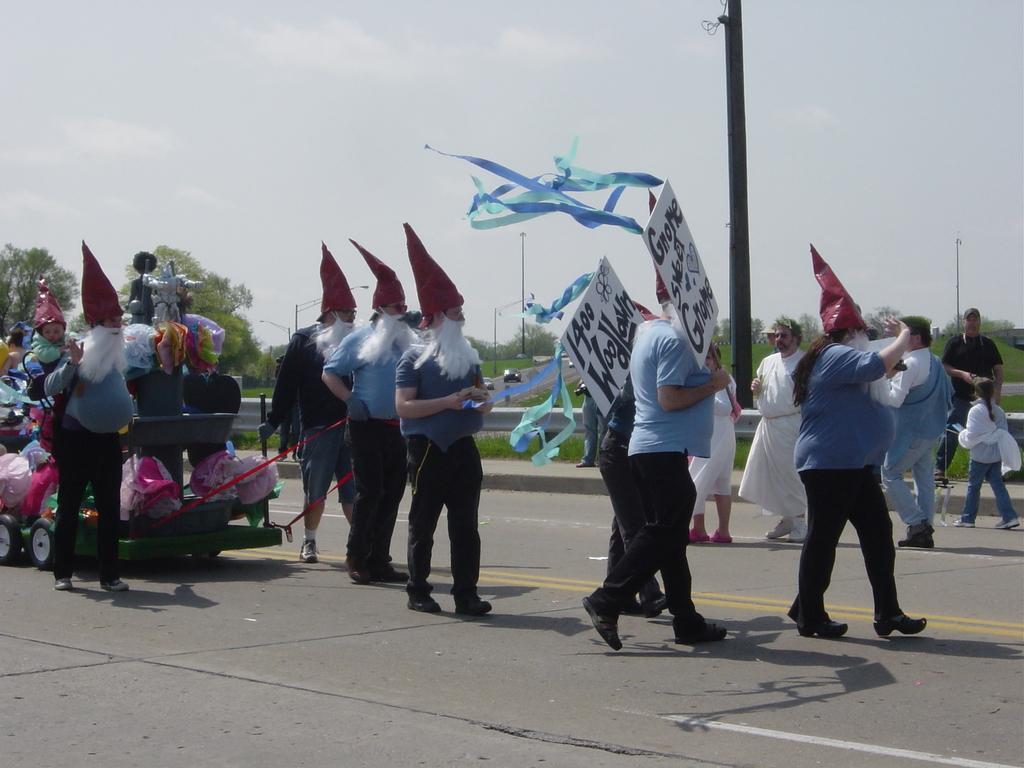Could you give a brief overview of what you see in this image? In this image we can see there are few people walking on the road, few are wearing a costume of a joker and some are holding a poster with some text and ribbons on it. On the left of the image there is a vehicle with some decoration. In the background there are few vehicles are on the road, trees and a sky. 